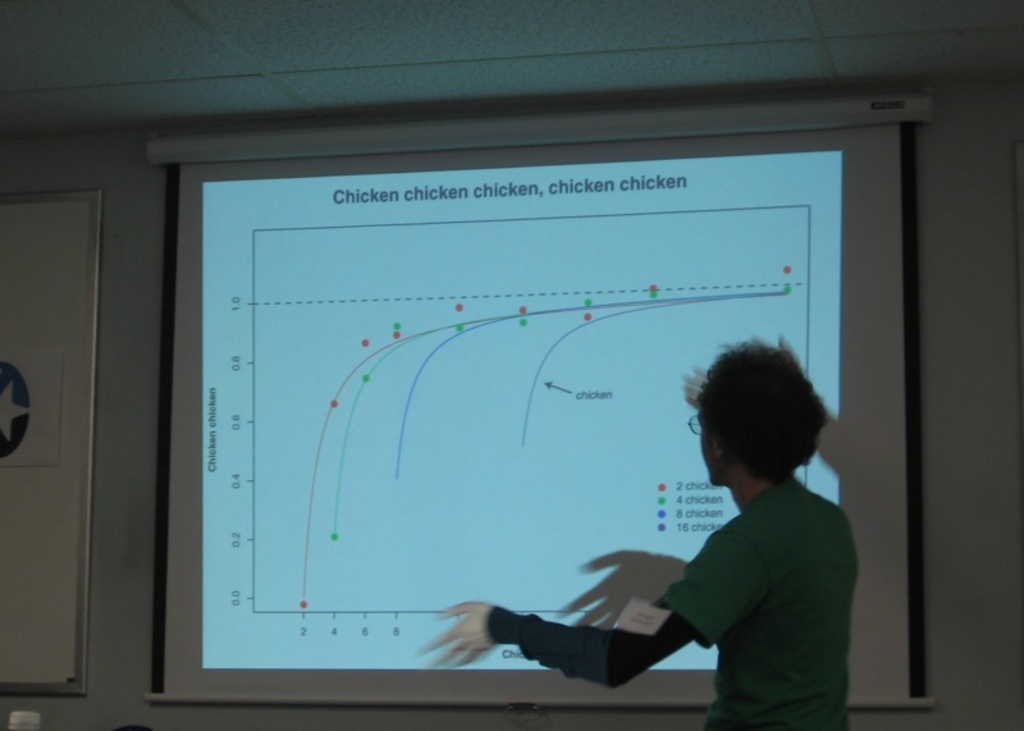What are the different colors on the chart indicating about chickens? Each color on the chart represents a different group of data showing how often the word 'chicken' appears in various contexts, highlighting a playful approach to data analysis. 